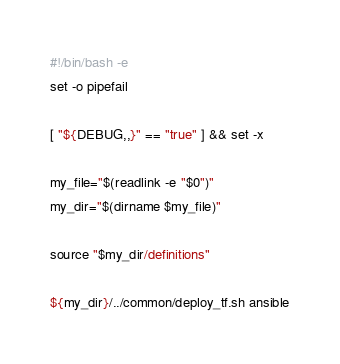Convert code to text. <code><loc_0><loc_0><loc_500><loc_500><_Bash_>#!/bin/bash -e
set -o pipefail

[ "${DEBUG,,}" == "true" ] && set -x

my_file="$(readlink -e "$0")"
my_dir="$(dirname $my_file)"

source "$my_dir/definitions"

${my_dir}/../common/deploy_tf.sh ansible
</code> 